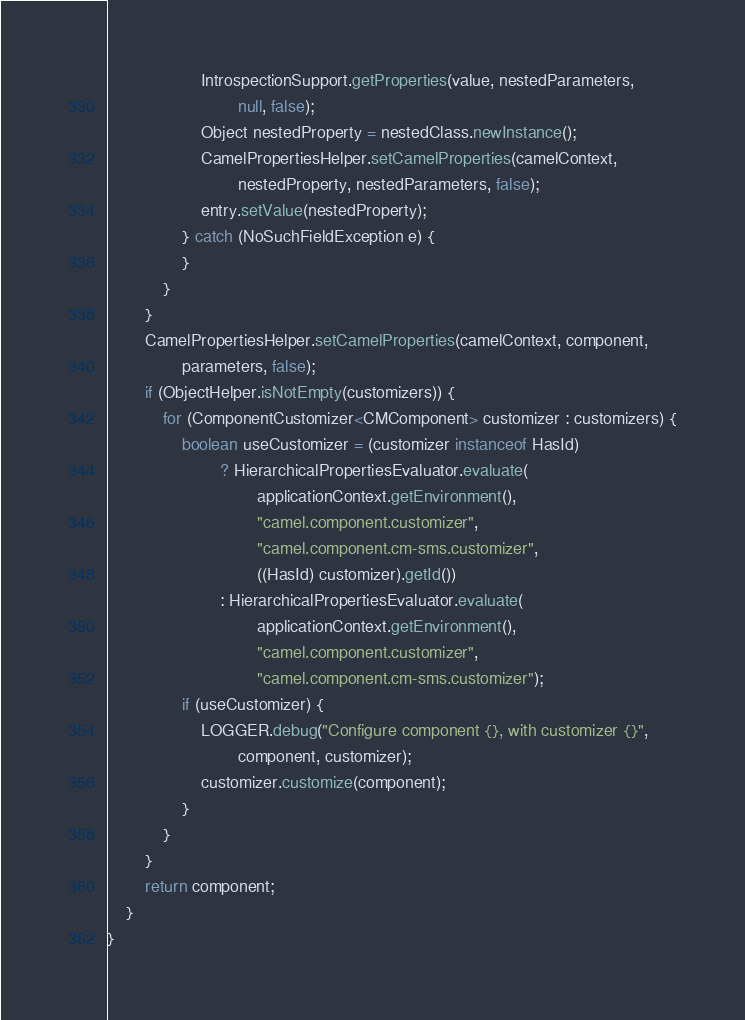Convert code to text. <code><loc_0><loc_0><loc_500><loc_500><_Java_>                    IntrospectionSupport.getProperties(value, nestedParameters,
                            null, false);
                    Object nestedProperty = nestedClass.newInstance();
                    CamelPropertiesHelper.setCamelProperties(camelContext,
                            nestedProperty, nestedParameters, false);
                    entry.setValue(nestedProperty);
                } catch (NoSuchFieldException e) {
                }
            }
        }
        CamelPropertiesHelper.setCamelProperties(camelContext, component,
                parameters, false);
        if (ObjectHelper.isNotEmpty(customizers)) {
            for (ComponentCustomizer<CMComponent> customizer : customizers) {
                boolean useCustomizer = (customizer instanceof HasId)
                        ? HierarchicalPropertiesEvaluator.evaluate(
                                applicationContext.getEnvironment(),
                                "camel.component.customizer",
                                "camel.component.cm-sms.customizer",
                                ((HasId) customizer).getId())
                        : HierarchicalPropertiesEvaluator.evaluate(
                                applicationContext.getEnvironment(),
                                "camel.component.customizer",
                                "camel.component.cm-sms.customizer");
                if (useCustomizer) {
                    LOGGER.debug("Configure component {}, with customizer {}",
                            component, customizer);
                    customizer.customize(component);
                }
            }
        }
        return component;
    }
}</code> 